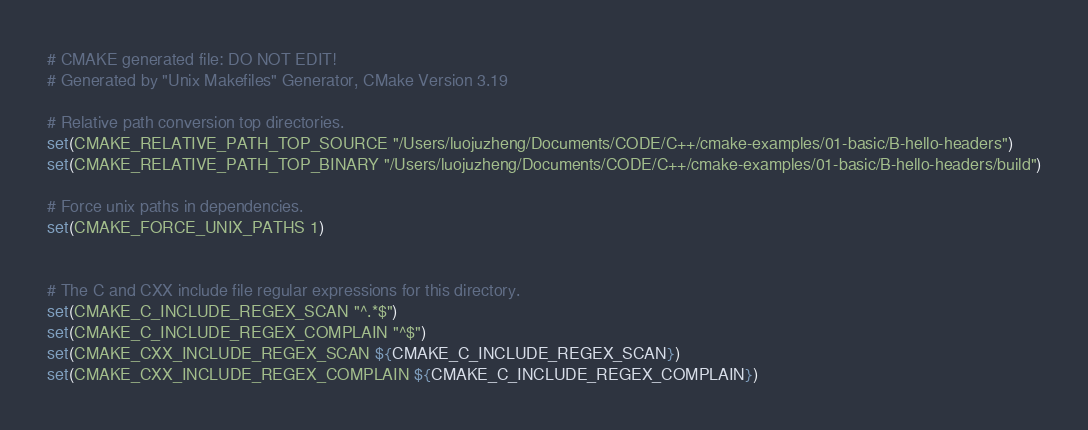Convert code to text. <code><loc_0><loc_0><loc_500><loc_500><_CMake_># CMAKE generated file: DO NOT EDIT!
# Generated by "Unix Makefiles" Generator, CMake Version 3.19

# Relative path conversion top directories.
set(CMAKE_RELATIVE_PATH_TOP_SOURCE "/Users/luojuzheng/Documents/CODE/C++/cmake-examples/01-basic/B-hello-headers")
set(CMAKE_RELATIVE_PATH_TOP_BINARY "/Users/luojuzheng/Documents/CODE/C++/cmake-examples/01-basic/B-hello-headers/build")

# Force unix paths in dependencies.
set(CMAKE_FORCE_UNIX_PATHS 1)


# The C and CXX include file regular expressions for this directory.
set(CMAKE_C_INCLUDE_REGEX_SCAN "^.*$")
set(CMAKE_C_INCLUDE_REGEX_COMPLAIN "^$")
set(CMAKE_CXX_INCLUDE_REGEX_SCAN ${CMAKE_C_INCLUDE_REGEX_SCAN})
set(CMAKE_CXX_INCLUDE_REGEX_COMPLAIN ${CMAKE_C_INCLUDE_REGEX_COMPLAIN})
</code> 